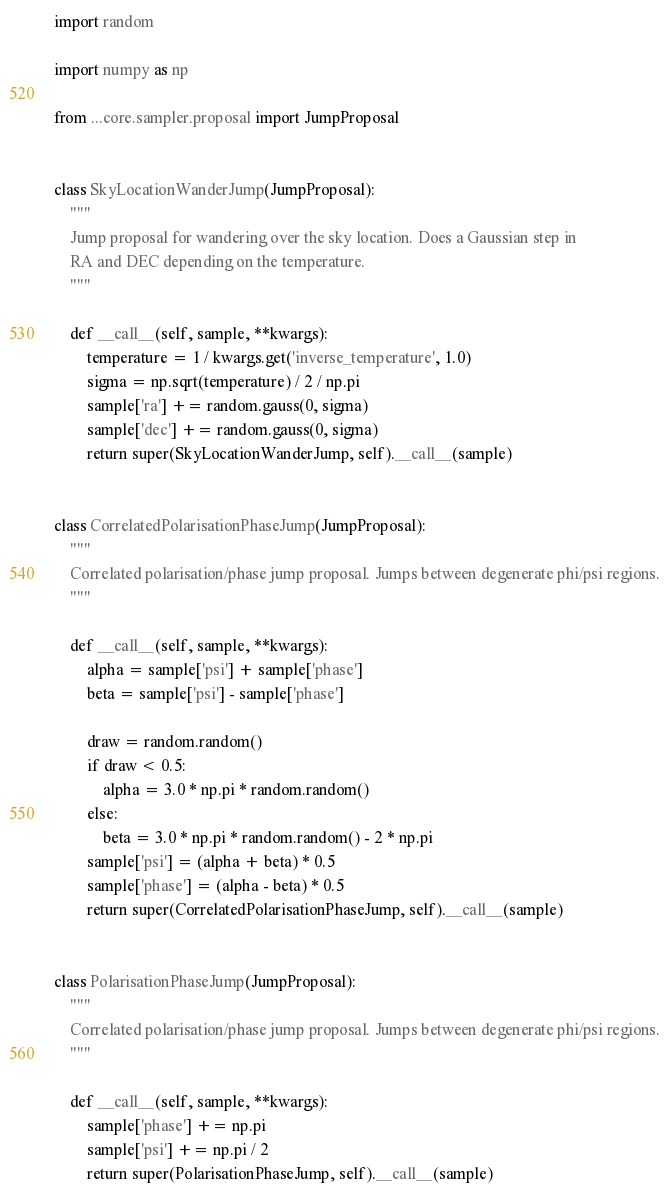Convert code to text. <code><loc_0><loc_0><loc_500><loc_500><_Python_>import random

import numpy as np

from ...core.sampler.proposal import JumpProposal


class SkyLocationWanderJump(JumpProposal):
    """
    Jump proposal for wandering over the sky location. Does a Gaussian step in
    RA and DEC depending on the temperature.
    """

    def __call__(self, sample, **kwargs):
        temperature = 1 / kwargs.get('inverse_temperature', 1.0)
        sigma = np.sqrt(temperature) / 2 / np.pi
        sample['ra'] += random.gauss(0, sigma)
        sample['dec'] += random.gauss(0, sigma)
        return super(SkyLocationWanderJump, self).__call__(sample)


class CorrelatedPolarisationPhaseJump(JumpProposal):
    """
    Correlated polarisation/phase jump proposal. Jumps between degenerate phi/psi regions.
    """

    def __call__(self, sample, **kwargs):
        alpha = sample['psi'] + sample['phase']
        beta = sample['psi'] - sample['phase']

        draw = random.random()
        if draw < 0.5:
            alpha = 3.0 * np.pi * random.random()
        else:
            beta = 3.0 * np.pi * random.random() - 2 * np.pi
        sample['psi'] = (alpha + beta) * 0.5
        sample['phase'] = (alpha - beta) * 0.5
        return super(CorrelatedPolarisationPhaseJump, self).__call__(sample)


class PolarisationPhaseJump(JumpProposal):
    """
    Correlated polarisation/phase jump proposal. Jumps between degenerate phi/psi regions.
    """

    def __call__(self, sample, **kwargs):
        sample['phase'] += np.pi
        sample['psi'] += np.pi / 2
        return super(PolarisationPhaseJump, self).__call__(sample)
</code> 